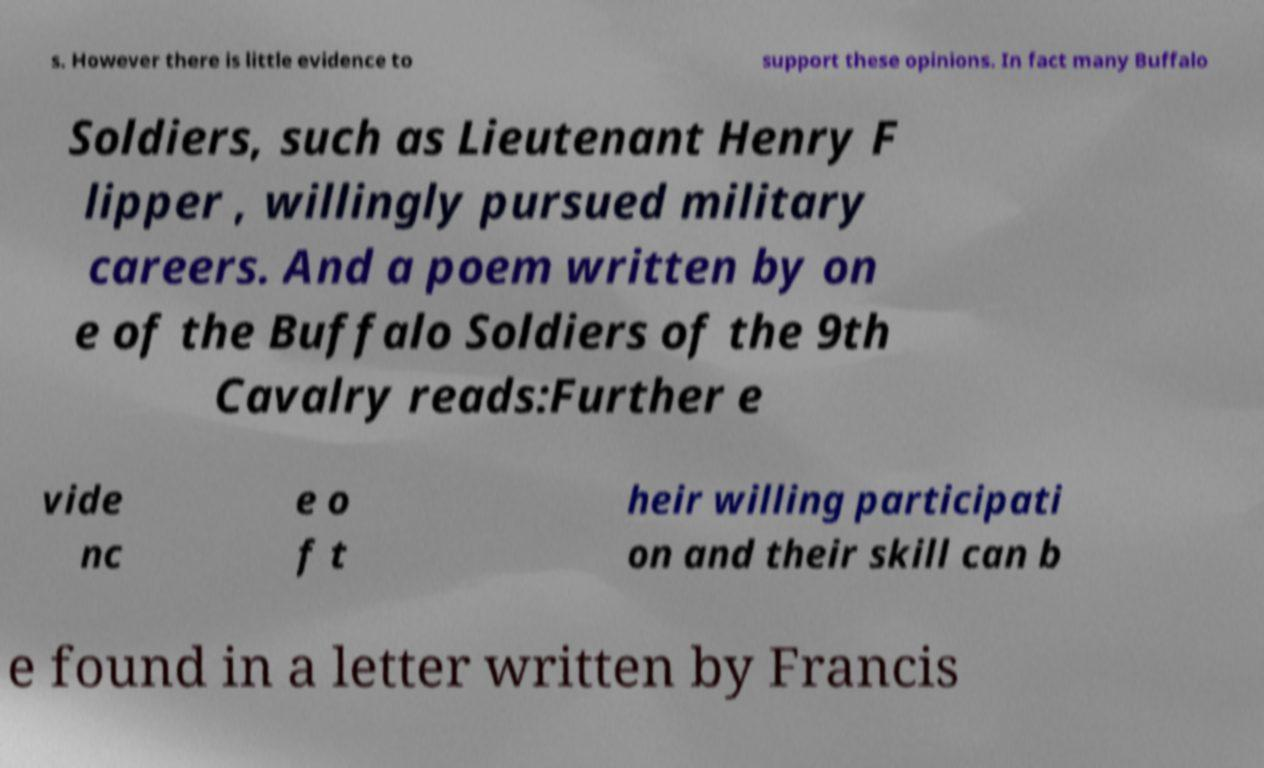Can you accurately transcribe the text from the provided image for me? s. However there is little evidence to support these opinions. In fact many Buffalo Soldiers, such as Lieutenant Henry F lipper , willingly pursued military careers. And a poem written by on e of the Buffalo Soldiers of the 9th Cavalry reads:Further e vide nc e o f t heir willing participati on and their skill can b e found in a letter written by Francis 